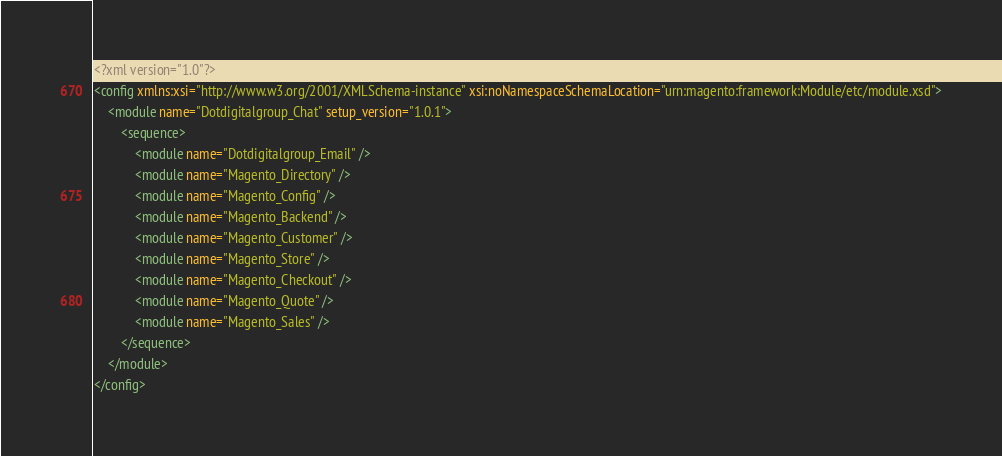Convert code to text. <code><loc_0><loc_0><loc_500><loc_500><_XML_><?xml version="1.0"?>
<config xmlns:xsi="http://www.w3.org/2001/XMLSchema-instance" xsi:noNamespaceSchemaLocation="urn:magento:framework:Module/etc/module.xsd">
    <module name="Dotdigitalgroup_Chat" setup_version="1.0.1">
        <sequence>
            <module name="Dotdigitalgroup_Email" />
            <module name="Magento_Directory" />
            <module name="Magento_Config" />
            <module name="Magento_Backend" />
            <module name="Magento_Customer" />
            <module name="Magento_Store" />
            <module name="Magento_Checkout" />
            <module name="Magento_Quote" />
            <module name="Magento_Sales" />
        </sequence>
    </module>
</config>
</code> 